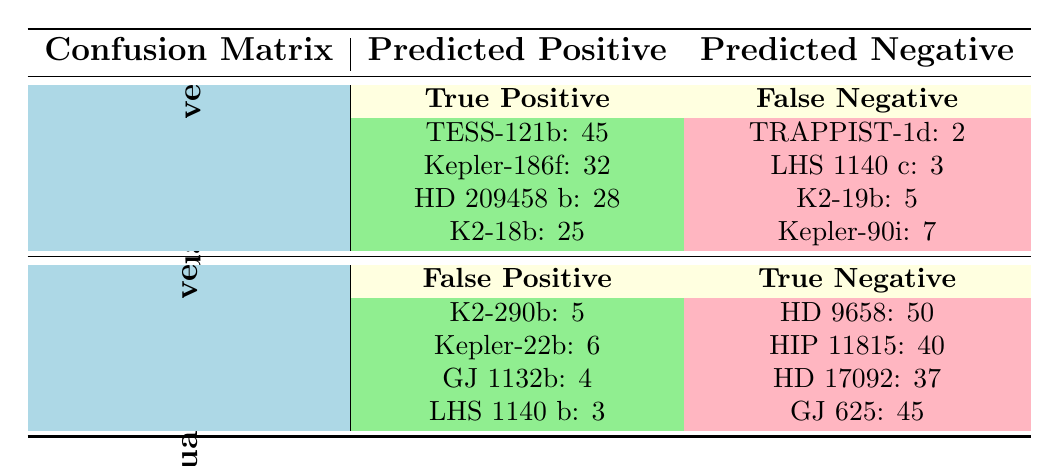What's the true positive count for TESS-121b? The table indicates under the "True Positive" section that the count for TESS-121b is 45.
Answer: 45 What is the total number of true negatives? To find the total true negatives, we sum the counts: 50 (HD 9658) + 40 (HIP 11815) + 37 (HD 17092) + 45 (GJ 625) = 172.
Answer: 172 Which exoplanet candidate had the highest false negative count? Looking at the "False Negative" section, we see that Kepler-90i has the highest count at 7.
Answer: Kepler-90i Is there a higher count of true positives or true negatives? The total true positives sum to 130 (45 + 32 + 28 + 25) and true negatives sum to 172. Thus, there are more true negatives.
Answer: True negatives What is the average number of false positives? The total false positives are 5 (K2-290b) + 6 (Kepler-22b) + 4 (GJ 1132b) + 3 (LHS 1140 b) = 18. There are 4 data points, so the average is 18 / 4 = 4.5.
Answer: 4.5 How many false negatives are there in total? Summing the counts in the "False Negative" section gives us 2 (TRAPPIST-1d) + 3 (LHS 1140 c) + 5 (K2-19b) + 7 (Kepler-90i) = 17.
Answer: 17 Is the count of true positives for HD 209458 b greater than for K2-18b? The true positive for HD 209458 b is 28 and for K2-18b is 25. Since 28 > 25, the statement is true.
Answer: Yes Which exoplanet candidate has the lowest false positive count? Among the false positives listed, LHS 1140 b has the lowest count at 3.
Answer: LHS 1140 b What is the total difference between true positives and false negatives? The true positives total 130 and false negatives total 17. The difference is 130 - 17 = 113.
Answer: 113 